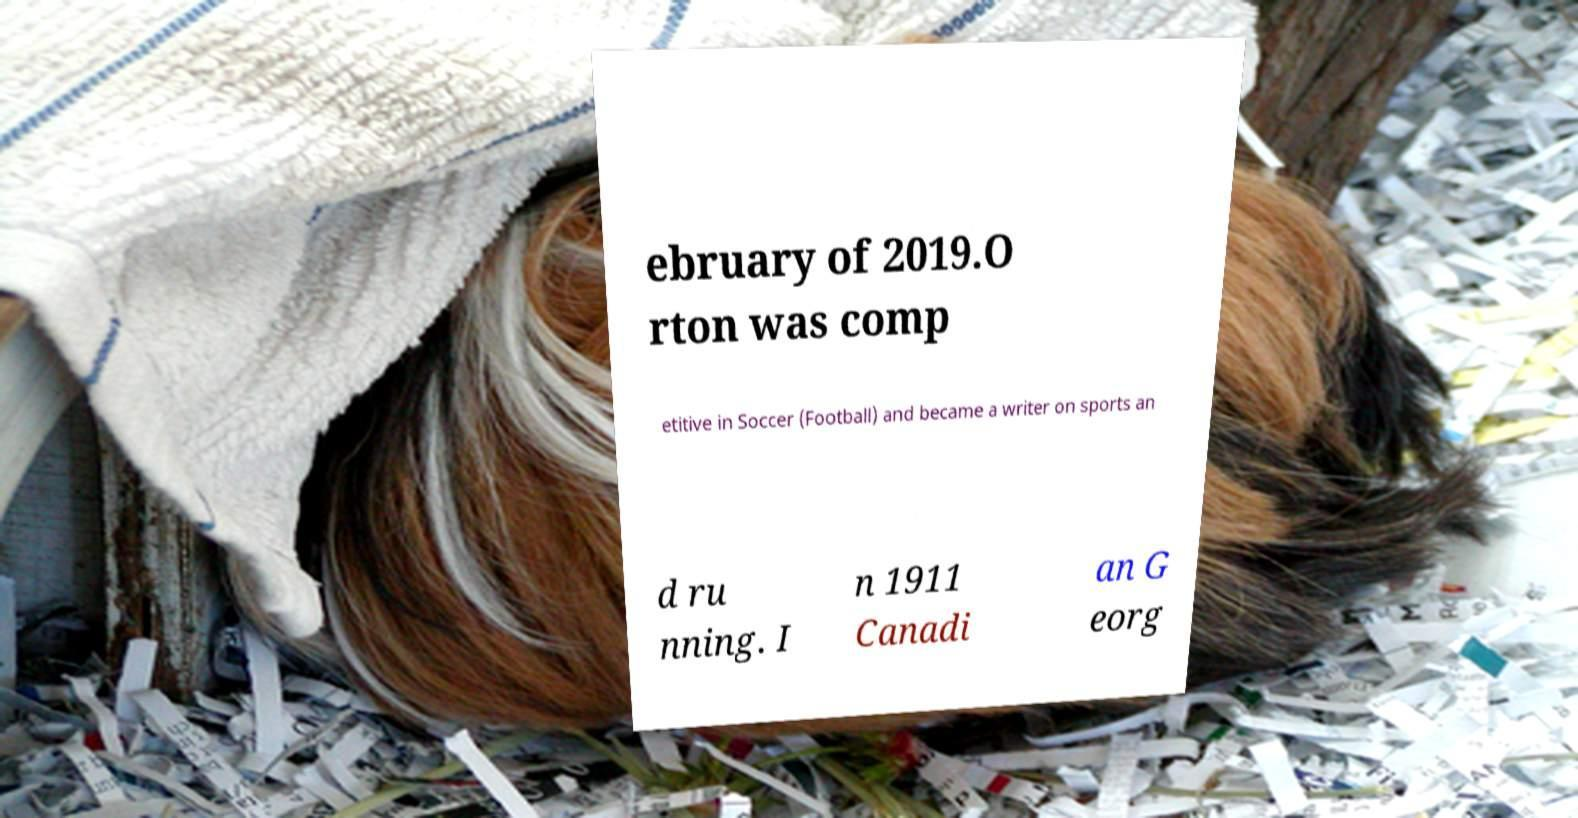What messages or text are displayed in this image? I need them in a readable, typed format. ebruary of 2019.O rton was comp etitive in Soccer (Football) and became a writer on sports an d ru nning. I n 1911 Canadi an G eorg 